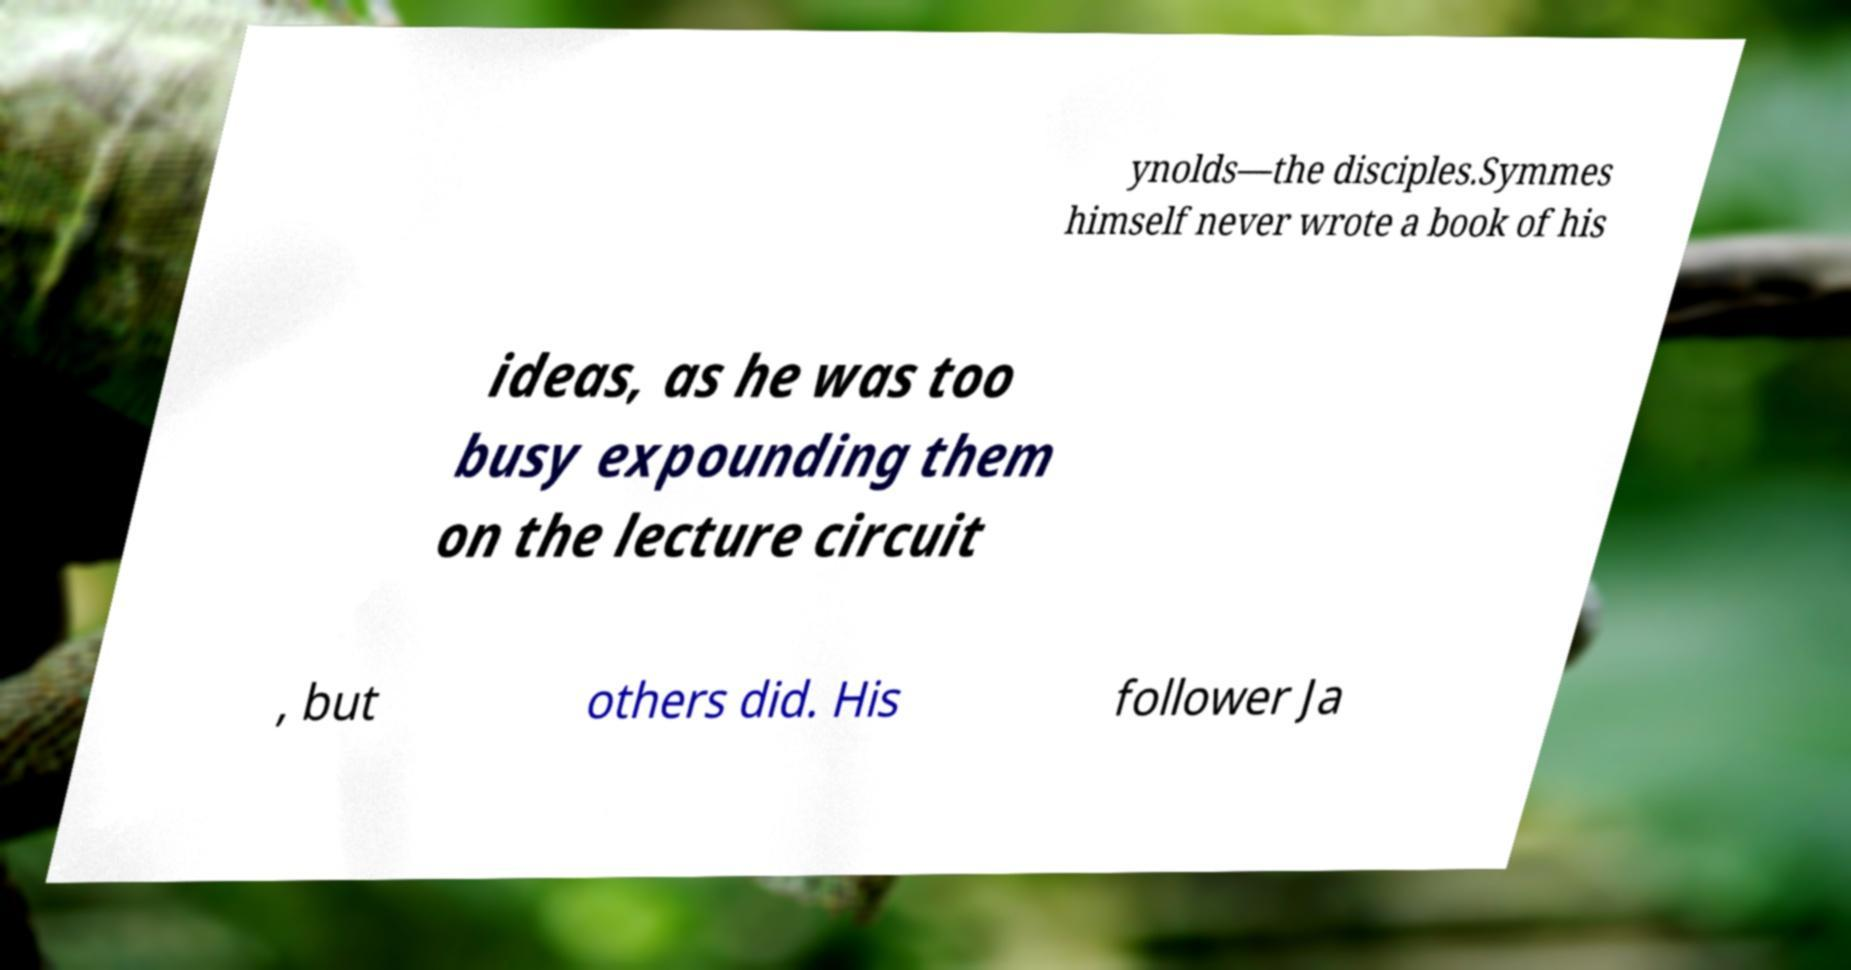Please identify and transcribe the text found in this image. ynolds—the disciples.Symmes himself never wrote a book of his ideas, as he was too busy expounding them on the lecture circuit , but others did. His follower Ja 